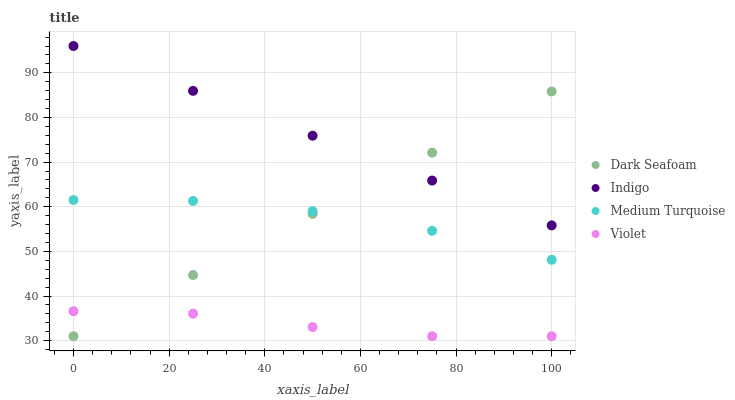Does Violet have the minimum area under the curve?
Answer yes or no. Yes. Does Indigo have the maximum area under the curve?
Answer yes or no. Yes. Does Medium Turquoise have the minimum area under the curve?
Answer yes or no. No. Does Medium Turquoise have the maximum area under the curve?
Answer yes or no. No. Is Dark Seafoam the smoothest?
Answer yes or no. Yes. Is Medium Turquoise the roughest?
Answer yes or no. Yes. Is Indigo the smoothest?
Answer yes or no. No. Is Indigo the roughest?
Answer yes or no. No. Does Dark Seafoam have the lowest value?
Answer yes or no. Yes. Does Medium Turquoise have the lowest value?
Answer yes or no. No. Does Indigo have the highest value?
Answer yes or no. Yes. Does Medium Turquoise have the highest value?
Answer yes or no. No. Is Medium Turquoise less than Indigo?
Answer yes or no. Yes. Is Medium Turquoise greater than Violet?
Answer yes or no. Yes. Does Violet intersect Dark Seafoam?
Answer yes or no. Yes. Is Violet less than Dark Seafoam?
Answer yes or no. No. Is Violet greater than Dark Seafoam?
Answer yes or no. No. Does Medium Turquoise intersect Indigo?
Answer yes or no. No. 